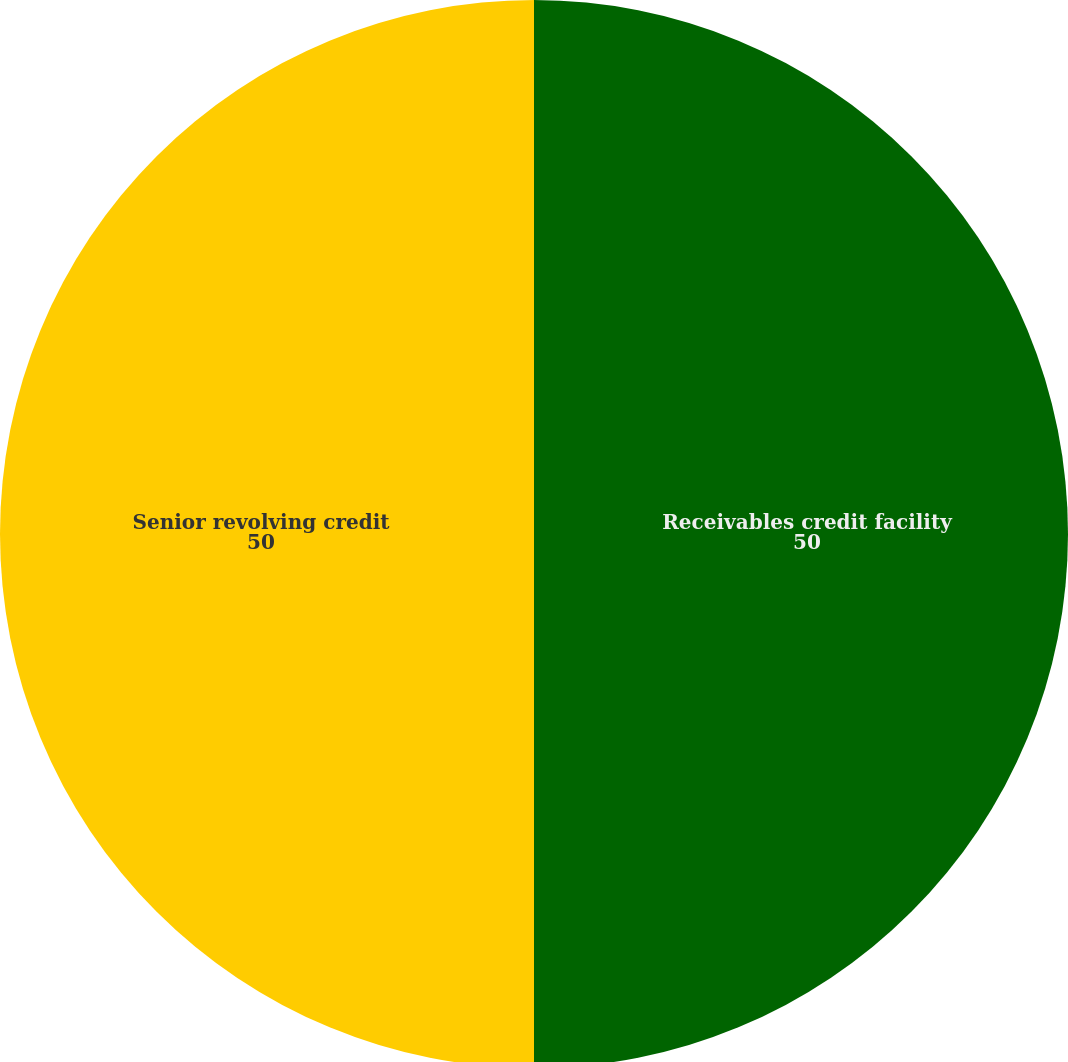Convert chart. <chart><loc_0><loc_0><loc_500><loc_500><pie_chart><fcel>Receivables credit facility<fcel>Senior revolving credit<nl><fcel>50.0%<fcel>50.0%<nl></chart> 